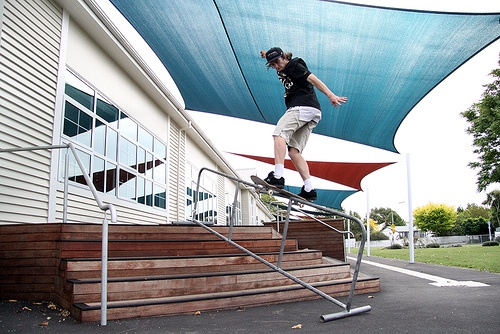Describe the objects in this image and their specific colors. I can see people in darkgray, black, lightgray, and pink tones and skateboard in darkgray, black, and gray tones in this image. 